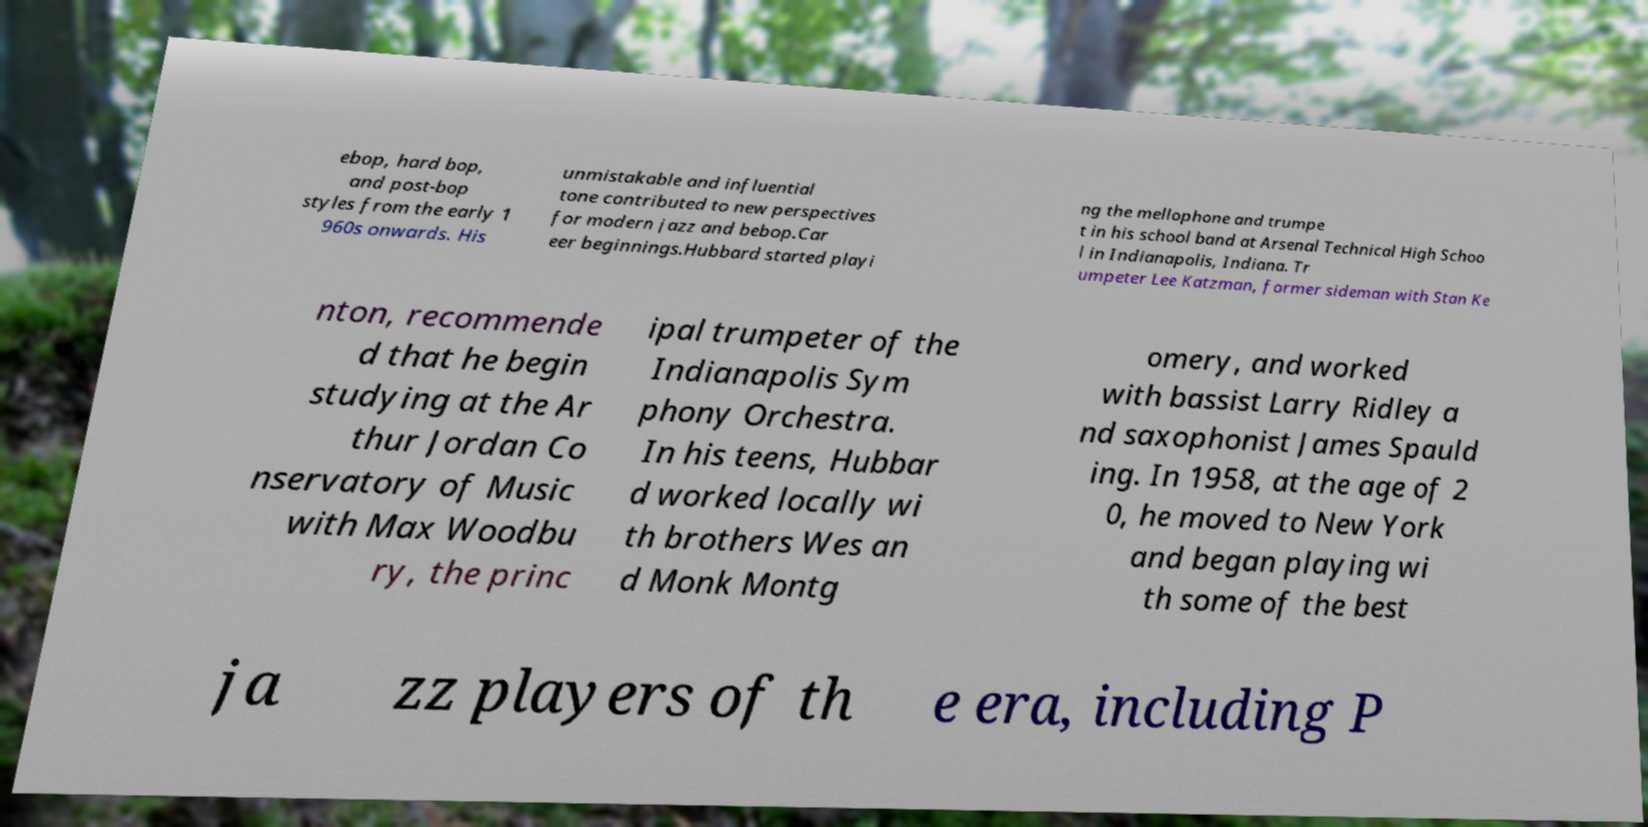Please identify and transcribe the text found in this image. ebop, hard bop, and post-bop styles from the early 1 960s onwards. His unmistakable and influential tone contributed to new perspectives for modern jazz and bebop.Car eer beginnings.Hubbard started playi ng the mellophone and trumpe t in his school band at Arsenal Technical High Schoo l in Indianapolis, Indiana. Tr umpeter Lee Katzman, former sideman with Stan Ke nton, recommende d that he begin studying at the Ar thur Jordan Co nservatory of Music with Max Woodbu ry, the princ ipal trumpeter of the Indianapolis Sym phony Orchestra. In his teens, Hubbar d worked locally wi th brothers Wes an d Monk Montg omery, and worked with bassist Larry Ridley a nd saxophonist James Spauld ing. In 1958, at the age of 2 0, he moved to New York and began playing wi th some of the best ja zz players of th e era, including P 